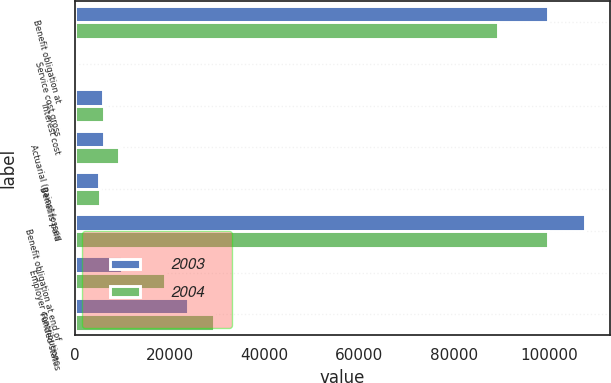Convert chart to OTSL. <chart><loc_0><loc_0><loc_500><loc_500><stacked_bar_chart><ecel><fcel>Benefit obligation at<fcel>Service cost gross<fcel>Interest cost<fcel>Actuarial (gains) losses<fcel>Benefits paid<fcel>Benefit obligation at end of<fcel>Employer contributions<fcel>Funded status<nl><fcel>2003<fcel>99795<fcel>506<fcel>6062<fcel>6139<fcel>5057<fcel>107445<fcel>10028<fcel>23820<nl><fcel>2004<fcel>89249<fcel>431<fcel>6129<fcel>9339<fcel>5353<fcel>99795<fcel>19028<fcel>29329<nl></chart> 